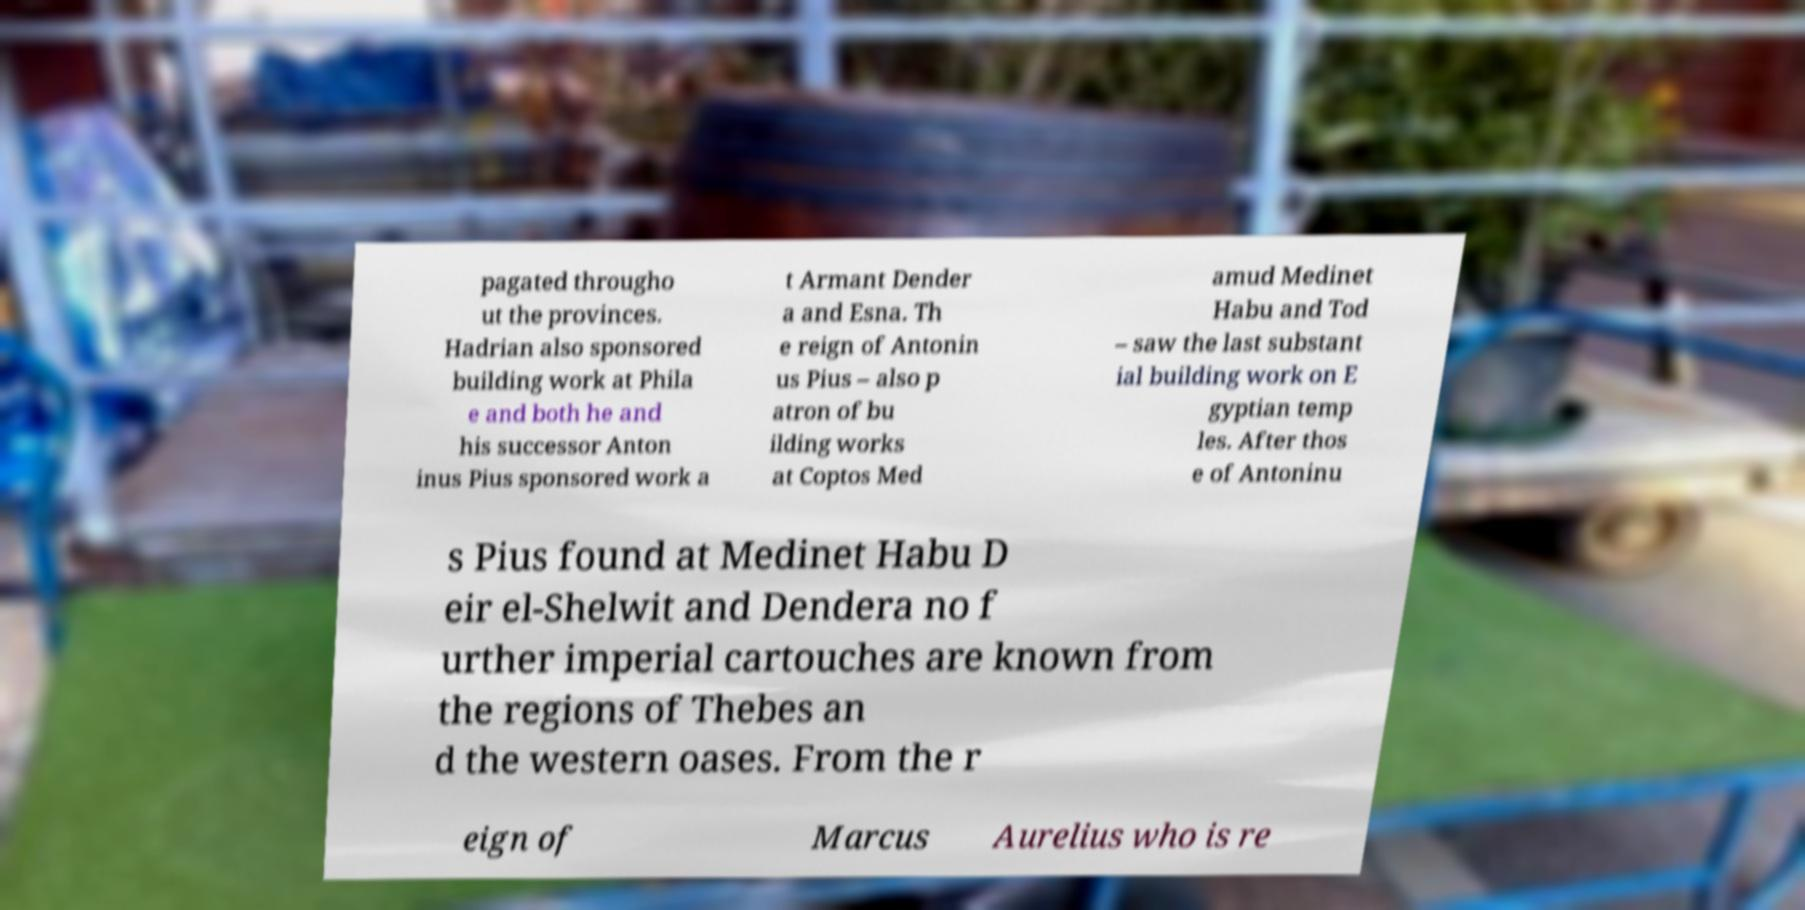Please read and relay the text visible in this image. What does it say? pagated througho ut the provinces. Hadrian also sponsored building work at Phila e and both he and his successor Anton inus Pius sponsored work a t Armant Dender a and Esna. Th e reign of Antonin us Pius – also p atron of bu ilding works at Coptos Med amud Medinet Habu and Tod – saw the last substant ial building work on E gyptian temp les. After thos e of Antoninu s Pius found at Medinet Habu D eir el-Shelwit and Dendera no f urther imperial cartouches are known from the regions of Thebes an d the western oases. From the r eign of Marcus Aurelius who is re 